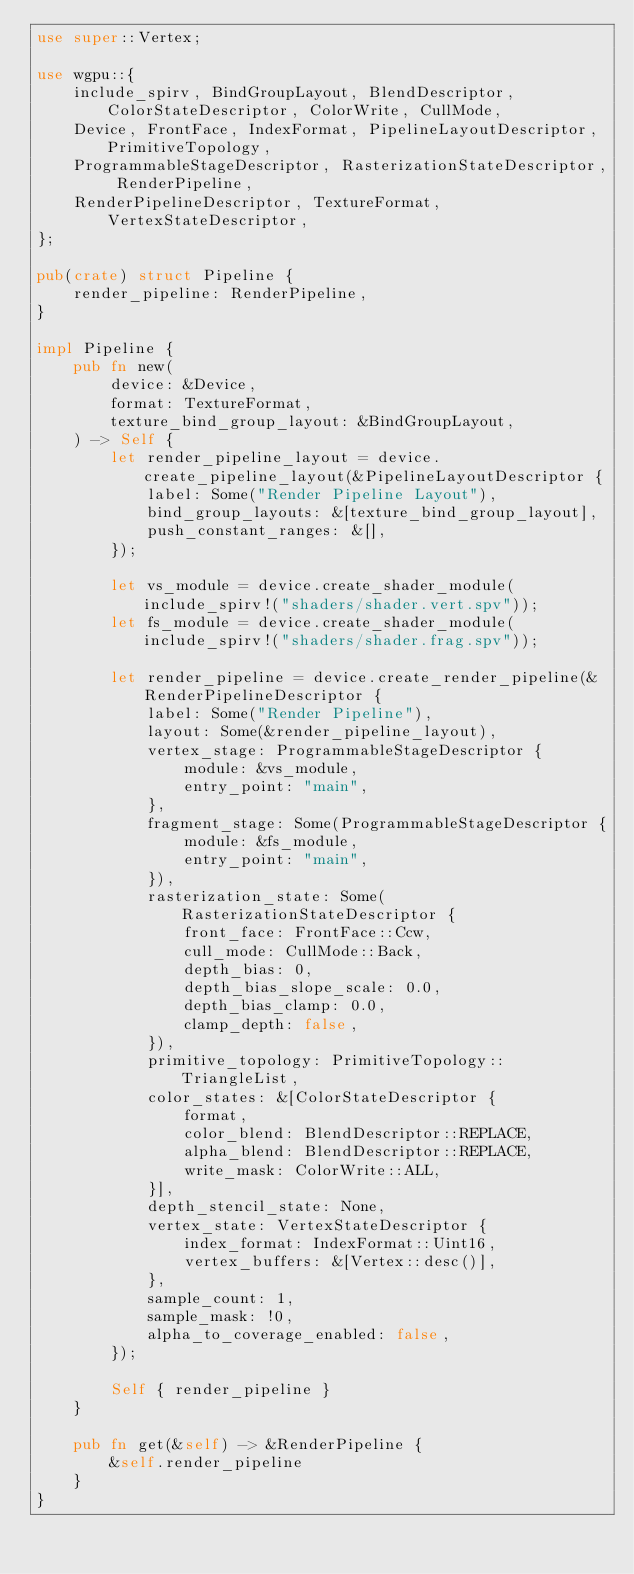Convert code to text. <code><loc_0><loc_0><loc_500><loc_500><_Rust_>use super::Vertex;

use wgpu::{
    include_spirv, BindGroupLayout, BlendDescriptor, ColorStateDescriptor, ColorWrite, CullMode,
    Device, FrontFace, IndexFormat, PipelineLayoutDescriptor, PrimitiveTopology,
    ProgrammableStageDescriptor, RasterizationStateDescriptor, RenderPipeline,
    RenderPipelineDescriptor, TextureFormat, VertexStateDescriptor,
};

pub(crate) struct Pipeline {
    render_pipeline: RenderPipeline,
}

impl Pipeline {
    pub fn new(
        device: &Device,
        format: TextureFormat,
        texture_bind_group_layout: &BindGroupLayout,
    ) -> Self {
        let render_pipeline_layout = device.create_pipeline_layout(&PipelineLayoutDescriptor {
            label: Some("Render Pipeline Layout"),
            bind_group_layouts: &[texture_bind_group_layout],
            push_constant_ranges: &[],
        });

        let vs_module = device.create_shader_module(include_spirv!("shaders/shader.vert.spv"));
        let fs_module = device.create_shader_module(include_spirv!("shaders/shader.frag.spv"));

        let render_pipeline = device.create_render_pipeline(&RenderPipelineDescriptor {
            label: Some("Render Pipeline"),
            layout: Some(&render_pipeline_layout),
            vertex_stage: ProgrammableStageDescriptor {
                module: &vs_module,
                entry_point: "main",
            },
            fragment_stage: Some(ProgrammableStageDescriptor {
                module: &fs_module,
                entry_point: "main",
            }),
            rasterization_state: Some(RasterizationStateDescriptor {
                front_face: FrontFace::Ccw,
                cull_mode: CullMode::Back,
                depth_bias: 0,
                depth_bias_slope_scale: 0.0,
                depth_bias_clamp: 0.0,
                clamp_depth: false,
            }),
            primitive_topology: PrimitiveTopology::TriangleList,
            color_states: &[ColorStateDescriptor {
                format,
                color_blend: BlendDescriptor::REPLACE,
                alpha_blend: BlendDescriptor::REPLACE,
                write_mask: ColorWrite::ALL,
            }],
            depth_stencil_state: None,
            vertex_state: VertexStateDescriptor {
                index_format: IndexFormat::Uint16,
                vertex_buffers: &[Vertex::desc()],
            },
            sample_count: 1,
            sample_mask: !0,
            alpha_to_coverage_enabled: false,
        });

        Self { render_pipeline }
    }

    pub fn get(&self) -> &RenderPipeline {
        &self.render_pipeline
    }
}
</code> 